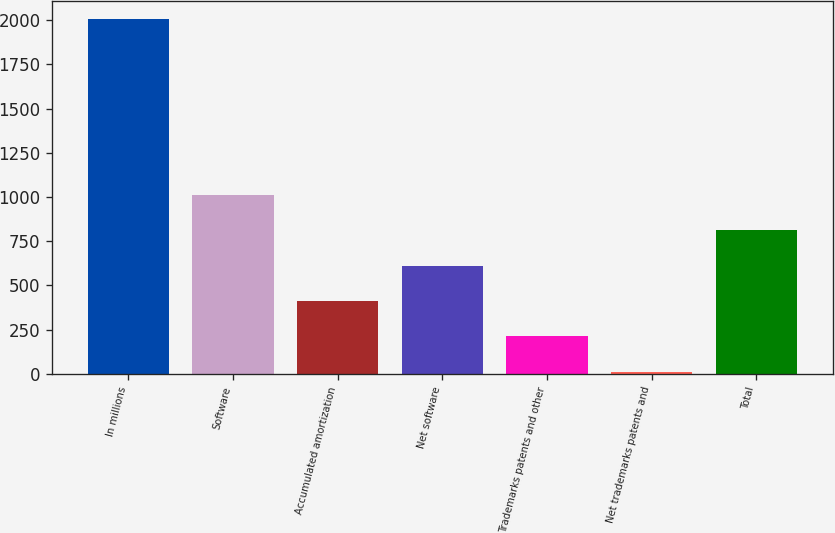<chart> <loc_0><loc_0><loc_500><loc_500><bar_chart><fcel>In millions<fcel>Software<fcel>Accumulated amortization<fcel>Net software<fcel>Trademarks patents and other<fcel>Net trademarks patents and<fcel>Total<nl><fcel>2009<fcel>1010<fcel>410.6<fcel>610.4<fcel>210.8<fcel>11<fcel>810.2<nl></chart> 